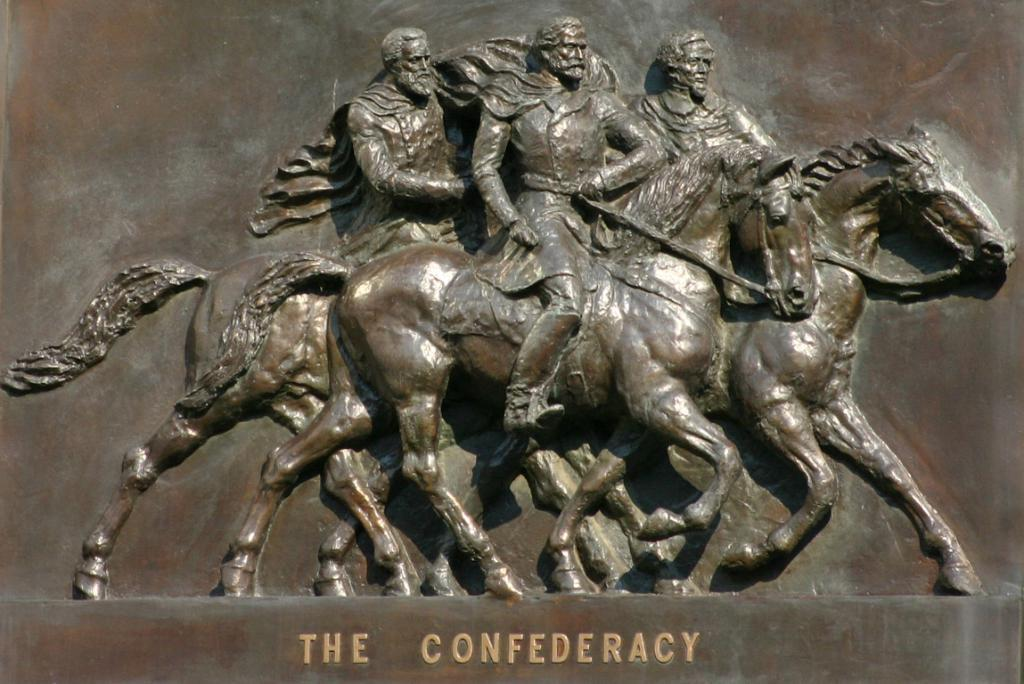What is the main subject of the image? There is a sculpture in the image. What type of gold bike is hidden in the sculpture as a surprise? There is no gold bike hidden in the sculpture, nor is there any mention of a surprise in the image. 